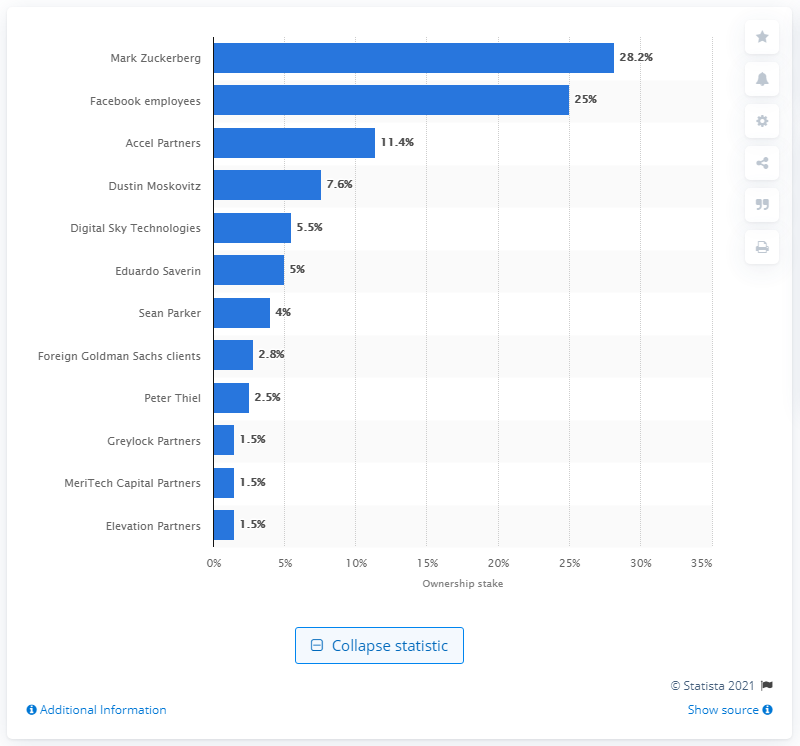Draw attention to some important aspects in this diagram. In June 2011, Sean Parker owned 4 percent of Facebook's stakes. In June 2011, Mark Zuckerberg owned 24% of Facebook. 